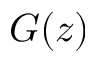<formula> <loc_0><loc_0><loc_500><loc_500>G ( z )</formula> 